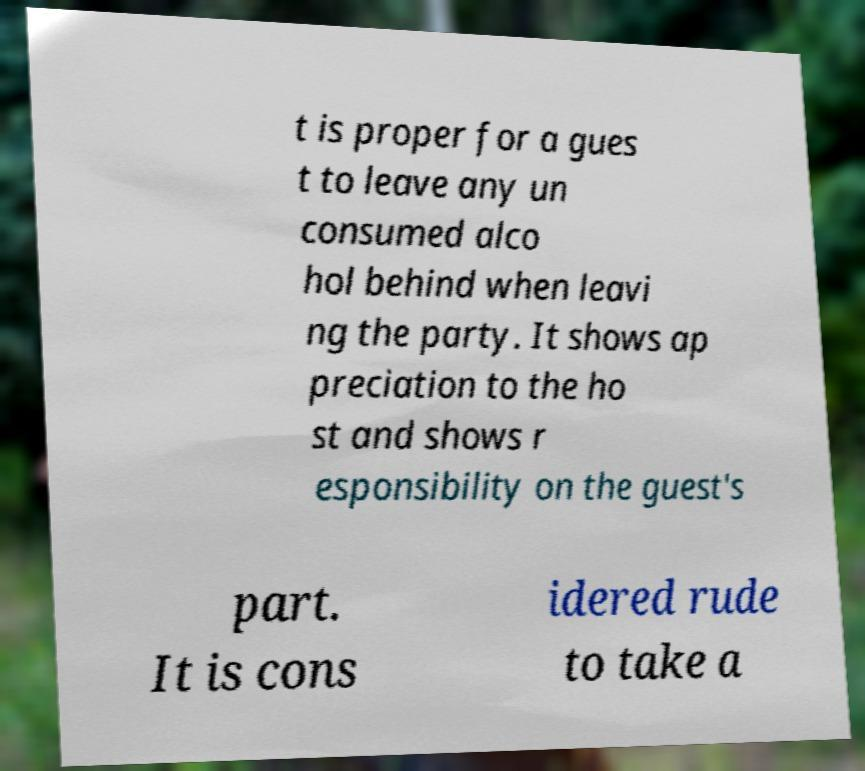Could you extract and type out the text from this image? t is proper for a gues t to leave any un consumed alco hol behind when leavi ng the party. It shows ap preciation to the ho st and shows r esponsibility on the guest's part. It is cons idered rude to take a 